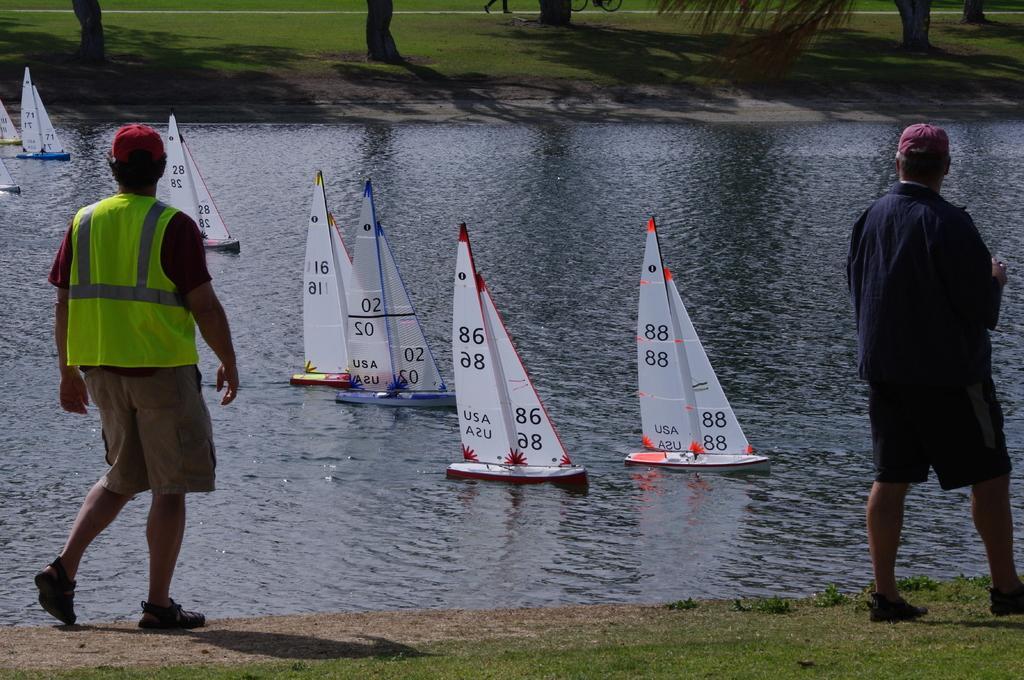Describe this image in one or two sentences. In this image we can see two persons standing and we can also see grass, boats and water. 